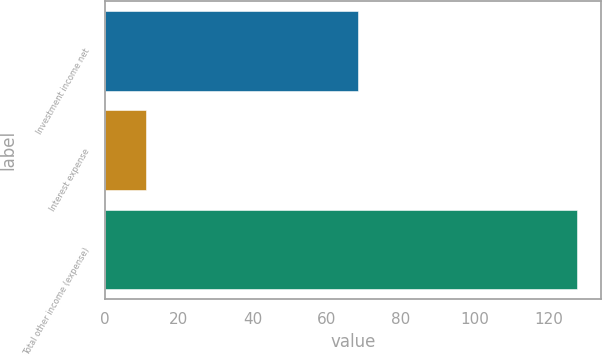Convert chart to OTSL. <chart><loc_0><loc_0><loc_500><loc_500><bar_chart><fcel>Investment income net<fcel>Interest expense<fcel>Total other income (expense)<nl><fcel>68.5<fcel>11.1<fcel>127.8<nl></chart> 